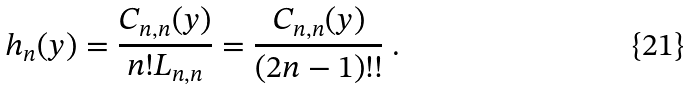<formula> <loc_0><loc_0><loc_500><loc_500>h _ { n } ( y ) = \frac { C _ { n , n } ( y ) } { n ! L _ { n , n } } = \frac { C _ { n , n } ( y ) } { ( 2 n - 1 ) ! ! } \ .</formula> 